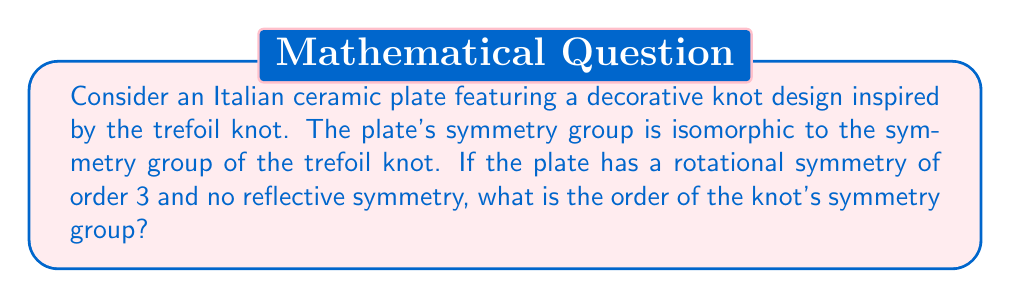Give your solution to this math problem. Let's approach this step-by-step:

1) The trefoil knot is one of the simplest non-trivial knots. Its symmetry group is isomorphic to the dihedral group $D_3$.

2) The dihedral group $D_3$ typically has 6 elements: 3 rotations and 3 reflections. However, our plate (and thus the knot) has no reflective symmetry.

3) The symmetry group of our knot consists only of rotational symmetries. We're told it has a rotational symmetry of order 3.

4) The rotational symmetries of $D_3$ are:
   - The identity rotation (0°)
   - Rotation by 120°
   - Rotation by 240°

5) These three rotations form a cyclic group of order 3, denoted as $C_3$.

6) Therefore, the symmetry group of our knot is isomorphic to $C_3$.

7) The order of a cyclic group $C_n$ is always $n$.

Therefore, the order of the knot's symmetry group is 3.
Answer: 3 